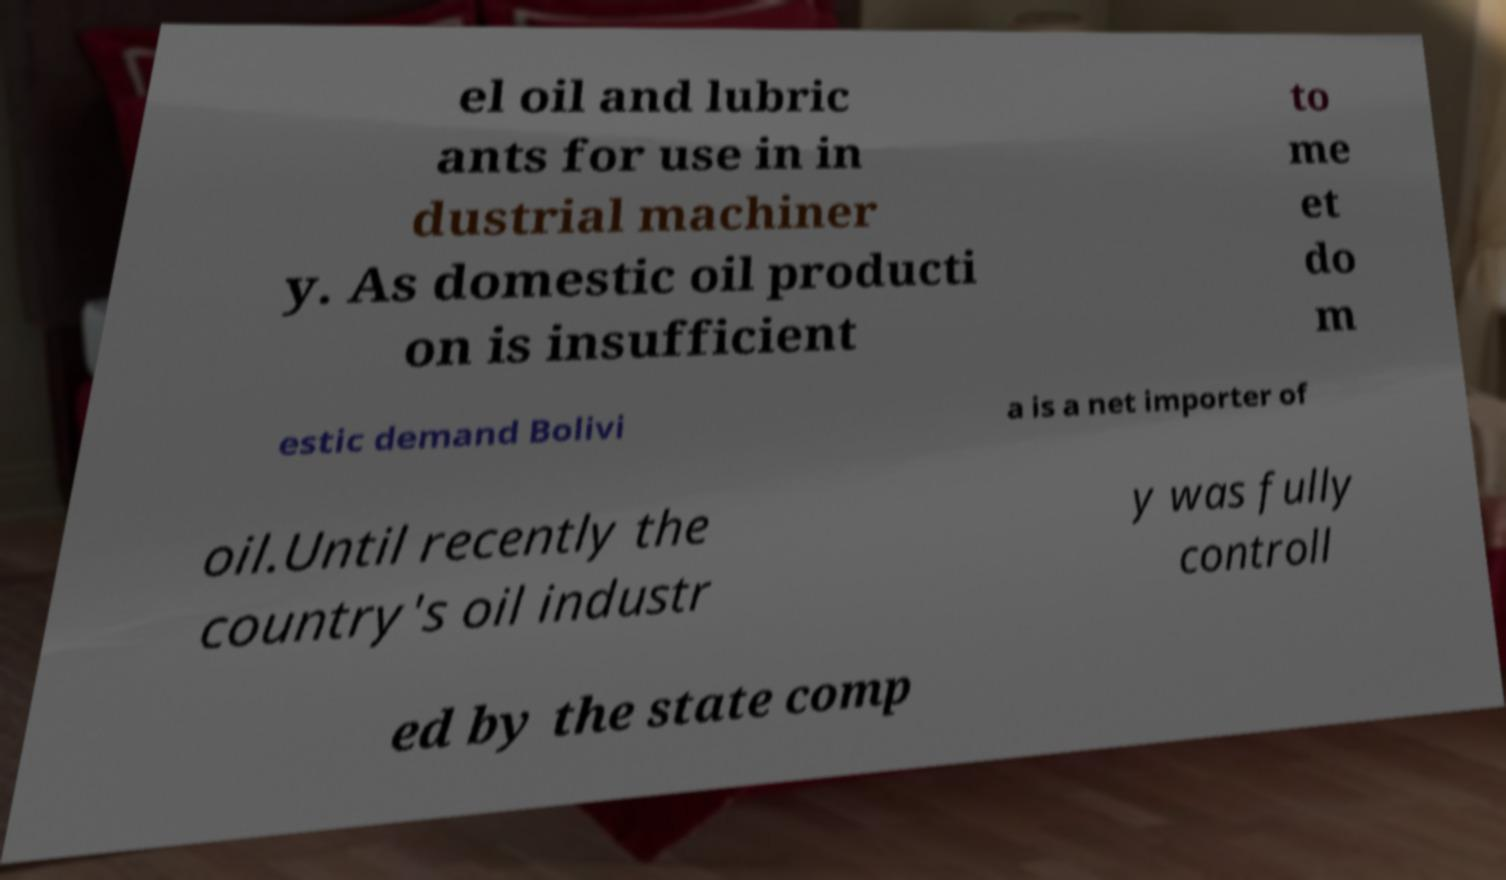What messages or text are displayed in this image? I need them in a readable, typed format. el oil and lubric ants for use in in dustrial machiner y. As domestic oil producti on is insufficient to me et do m estic demand Bolivi a is a net importer of oil.Until recently the country's oil industr y was fully controll ed by the state comp 